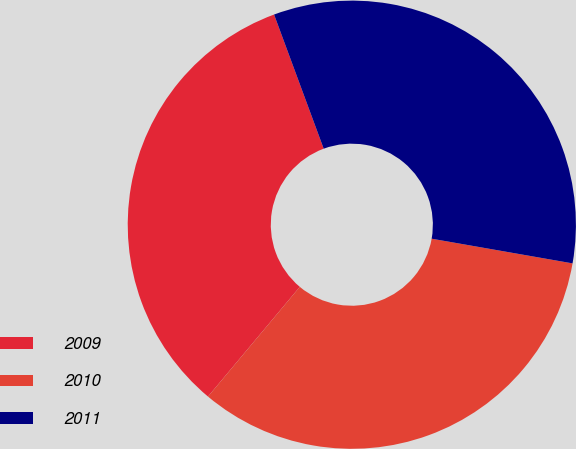<chart> <loc_0><loc_0><loc_500><loc_500><pie_chart><fcel>2009<fcel>2010<fcel>2011<nl><fcel>33.27%<fcel>33.33%<fcel>33.4%<nl></chart> 